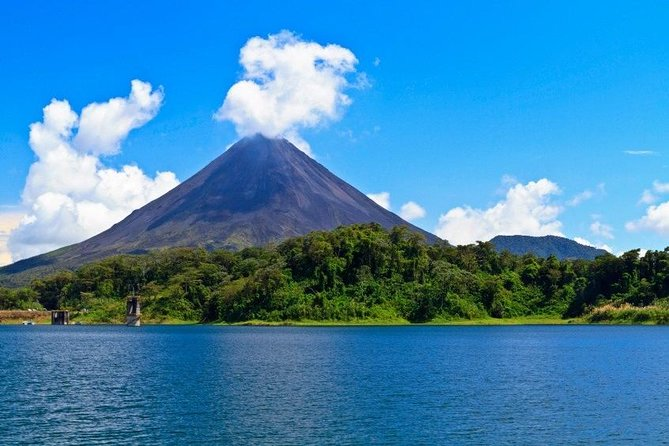What is this photo about'? The image captures the majestic Arenal Volcano, a renowned landmark in Costa Rica. The volcano, with its peak prominently visible, stands as the central focus of the image. Its surroundings are a testament to the rich biodiversity of the region, with a lush green landscape enveloping the base of the volcano. A body of water in the foreground adds a serene element to the scene. The sky above is a clear blue, dotted with a few scattered clouds. The image is taken from a distance, offering a wide perspective that encompasses the grandeur of the volcano and the beauty of its surroundings. The colors, objects, and perspective in the image all contribute to a vivid depiction of this worldwide landmark. 